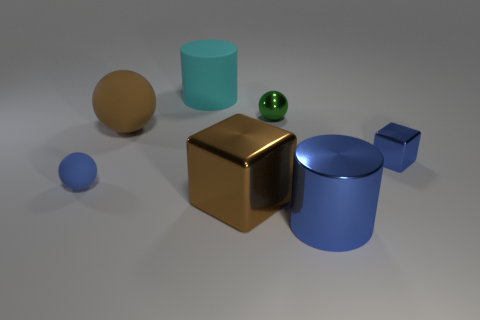Are there fewer brown cubes that are to the right of the green ball than tiny yellow matte blocks?
Make the answer very short. No. The green thing that is made of the same material as the large brown block is what shape?
Make the answer very short. Sphere. Are the large cyan object and the blue cube made of the same material?
Make the answer very short. No. Are there fewer things that are right of the rubber cylinder than things that are behind the brown metallic thing?
Your response must be concise. Yes. What is the size of the metallic block that is the same color as the big ball?
Provide a short and direct response. Large. How many large rubber objects are on the right side of the cylinder behind the brown block to the left of the small green object?
Offer a terse response. 0. Does the big shiny cube have the same color as the small metallic block?
Make the answer very short. No. Is there another ball that has the same color as the metallic sphere?
Offer a very short reply. No. There is a metallic object that is the same size as the brown cube; what is its color?
Your answer should be very brief. Blue. Is there a blue metallic object of the same shape as the brown metallic thing?
Provide a succinct answer. Yes. 